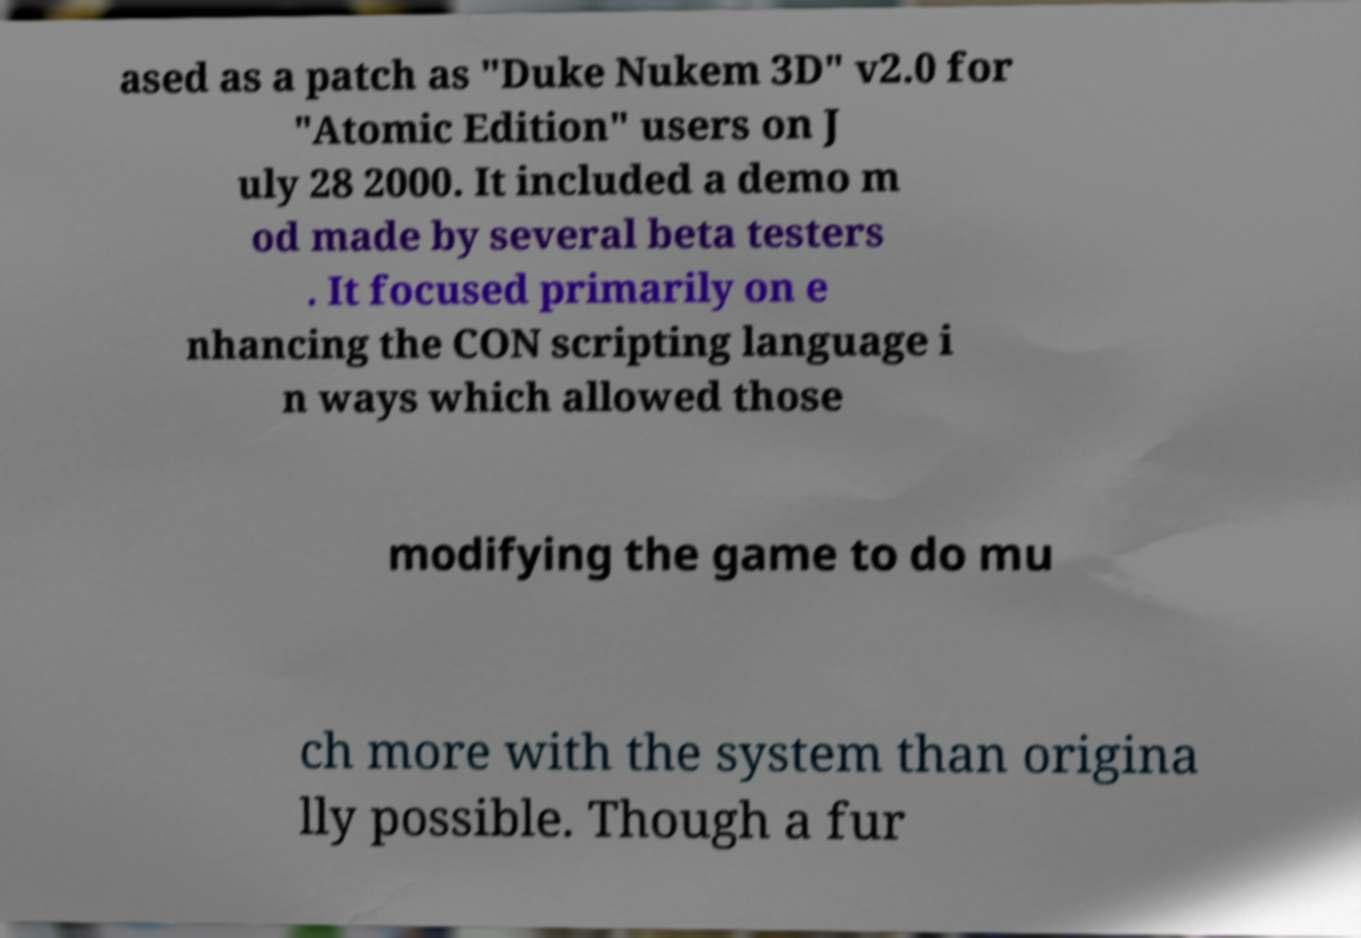Can you read and provide the text displayed in the image?This photo seems to have some interesting text. Can you extract and type it out for me? ased as a patch as "Duke Nukem 3D" v2.0 for "Atomic Edition" users on J uly 28 2000. It included a demo m od made by several beta testers . It focused primarily on e nhancing the CON scripting language i n ways which allowed those modifying the game to do mu ch more with the system than origina lly possible. Though a fur 